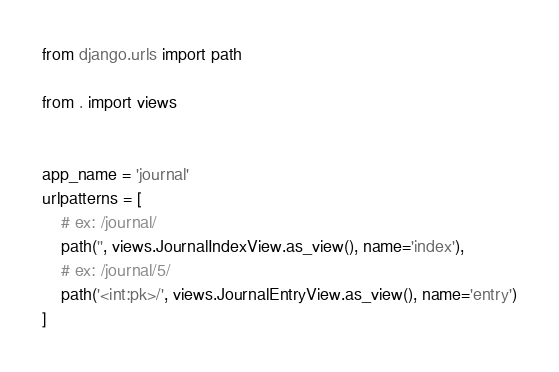<code> <loc_0><loc_0><loc_500><loc_500><_Python_>from django.urls import path

from . import views


app_name = 'journal'
urlpatterns = [
    # ex: /journal/
    path('', views.JournalIndexView.as_view(), name='index'),
    # ex: /journal/5/
    path('<int:pk>/', views.JournalEntryView.as_view(), name='entry')
]
</code> 